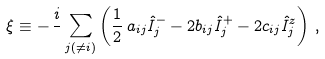<formula> <loc_0><loc_0><loc_500><loc_500>\xi \equiv - \, \frac { i } { } \sum _ { j ( \neq i ) } \left ( \frac { 1 } { 2 } \, a _ { i j } \hat { I } _ { j } ^ { - } - 2 b _ { i j } \hat { I } _ { j } ^ { + } - 2 c _ { i j } \hat { I } _ { j } ^ { z } \right ) \, ,</formula> 